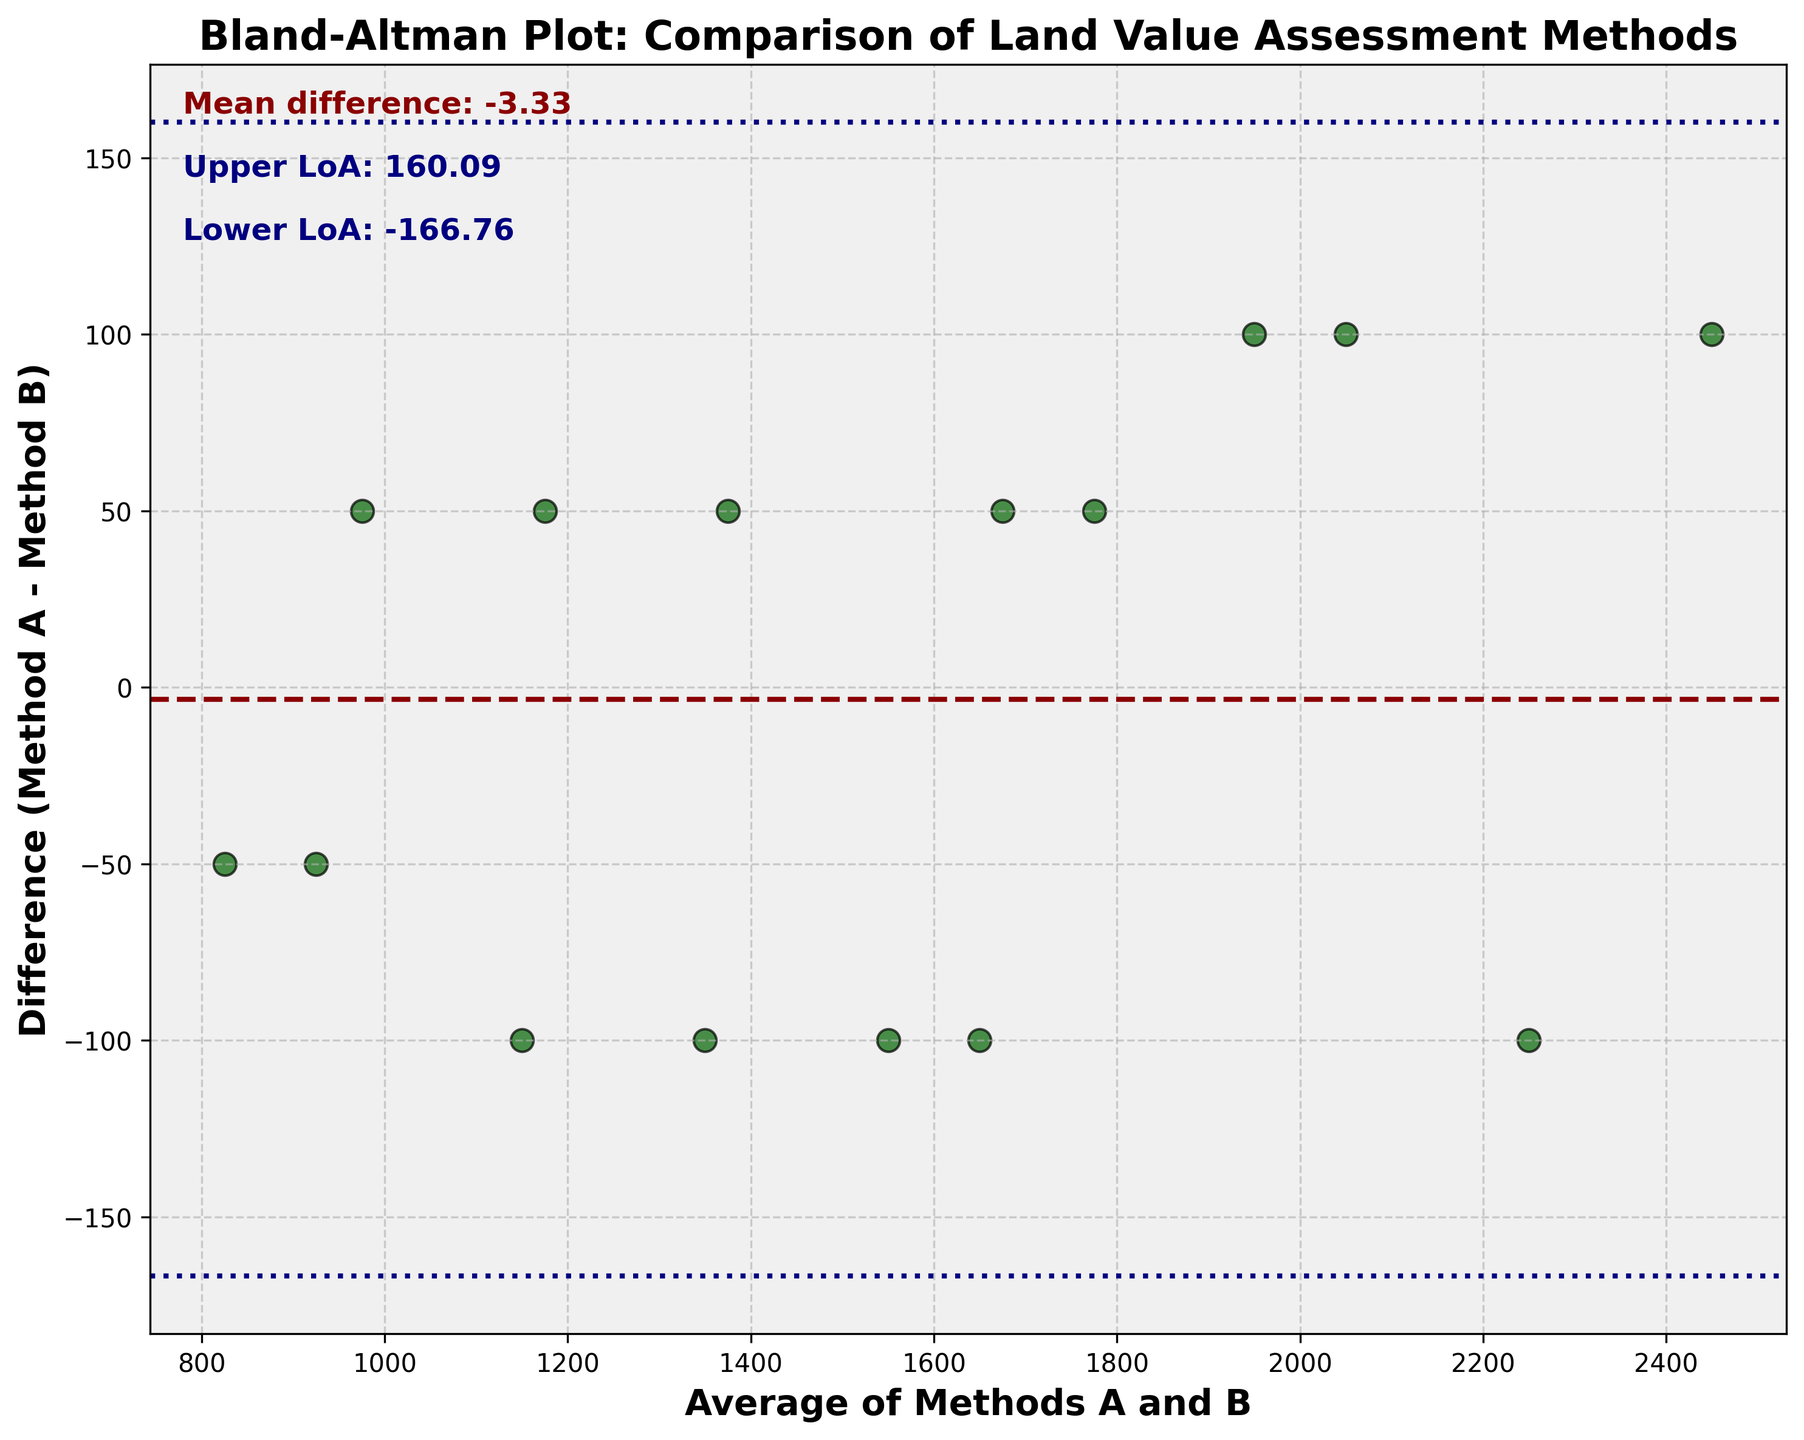How many data points are plotted in the graph? By visually counting the number of scatter points in the figure, you can identify the total number of data points.
Answer: 15 What is the title of the plot? The title is usually located at the top of the figure within the plotting area. Look for the text that describes what the plot represents.
Answer: Bland-Altman Plot: Comparison of Land Value Assessment Methods What is measured on the x-axis? The x-axis label indicates what is plotted on the horizontal axis. Examine the axis label for this information.
Answer: Average of Methods A and B What color is used for the scatter points? The appearance of scatter points in the plot can be described by their color and visual style. Visually inspect the scatter points to determine their color.
Answer: Dark green What are the upper and lower limits of agreement in the plot? The limits of agreement are usually marked by horizontal lines in a Bland–Altman plot. The values can typically be read directly from the text annotations or by determining where these lines intersect the y-axis.
Answer: Upper LoA: 109.95, Lower LoA: -176.62 What is the mean difference between Method A and Method B? The mean difference is often displayed as a horizontal line in a Bland–Altman plot and labeled textually. Locate this information from the annotated text on the plot.
Answer: -33.33 Which value pair has the greatest positive difference between Method A and Method B? Identify the value pairs and subtract Method B from Method A for each pair. The pair with the highest positive result is the greatest positive difference.
Answer: (1500,1600), difference = -100 Are there more points where Method A is greater than Method B or vice versa? To determine this, carefully inspect each data point or calculation to see if Method A values are typically greater or less than the Method B values. Compare the counts of each occurrence.
Answer: Method A is greater How many data points fall within the limits of agreement? Count the number of data points whose differences fall within the range defined by the upper and lower limits of agreement. This is the count of data points that lie between these horizontal lines.
Answer: 14 What visual element distinguishes the mean difference line from the limits of agreement? Observe the plotting styles used in the figure. Notice differences in line style, color, or thickness that distinguish the mean difference line from the limits of agreement lines.
Answer: Line style: dashed for mean difference, dotted for limits 